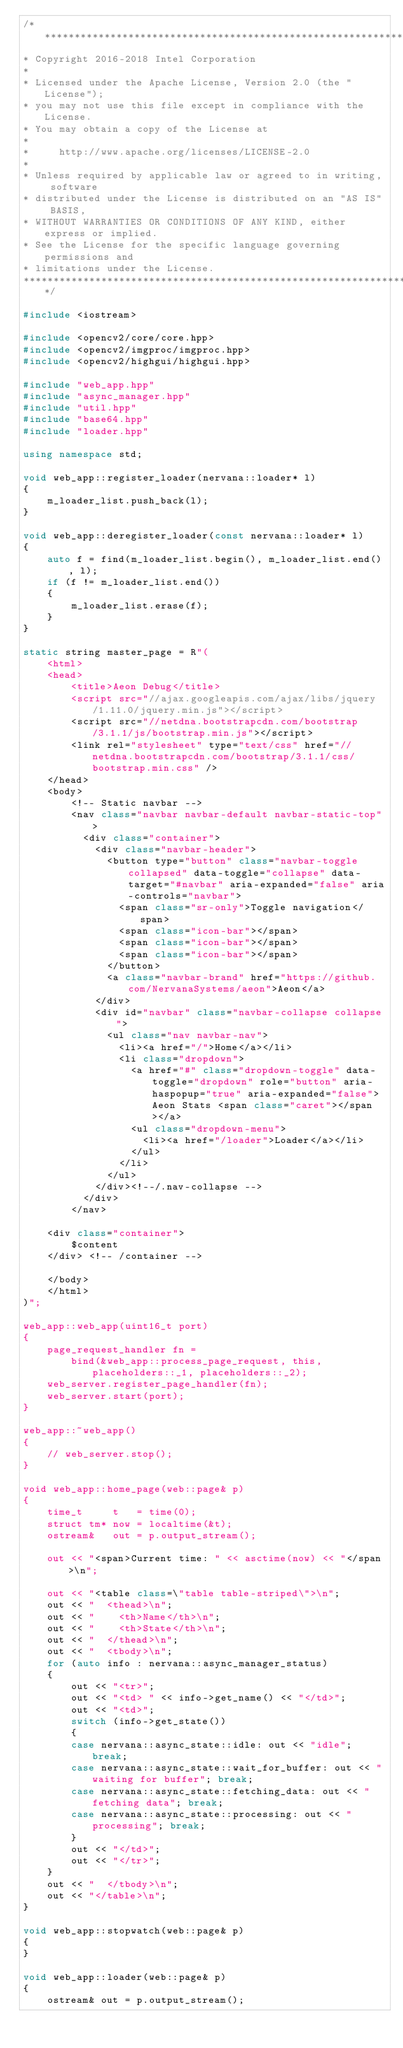<code> <loc_0><loc_0><loc_500><loc_500><_C++_>/*******************************************************************************
* Copyright 2016-2018 Intel Corporation
*
* Licensed under the Apache License, Version 2.0 (the "License");
* you may not use this file except in compliance with the License.
* You may obtain a copy of the License at
*
*     http://www.apache.org/licenses/LICENSE-2.0
*
* Unless required by applicable law or agreed to in writing, software
* distributed under the License is distributed on an "AS IS" BASIS,
* WITHOUT WARRANTIES OR CONDITIONS OF ANY KIND, either express or implied.
* See the License for the specific language governing permissions and
* limitations under the License.
*******************************************************************************/

#include <iostream>

#include <opencv2/core/core.hpp>
#include <opencv2/imgproc/imgproc.hpp>
#include <opencv2/highgui/highgui.hpp>

#include "web_app.hpp"
#include "async_manager.hpp"
#include "util.hpp"
#include "base64.hpp"
#include "loader.hpp"

using namespace std;

void web_app::register_loader(nervana::loader* l)
{
    m_loader_list.push_back(l);
}

void web_app::deregister_loader(const nervana::loader* l)
{
    auto f = find(m_loader_list.begin(), m_loader_list.end(), l);
    if (f != m_loader_list.end())
    {
        m_loader_list.erase(f);
    }
}

static string master_page = R"(
    <html>
    <head>
        <title>Aeon Debug</title>
        <script src="//ajax.googleapis.com/ajax/libs/jquery/1.11.0/jquery.min.js"></script>
        <script src="//netdna.bootstrapcdn.com/bootstrap/3.1.1/js/bootstrap.min.js"></script>
        <link rel="stylesheet" type="text/css" href="//netdna.bootstrapcdn.com/bootstrap/3.1.1/css/bootstrap.min.css" />
    </head>
    <body>
        <!-- Static navbar -->
        <nav class="navbar navbar-default navbar-static-top">
          <div class="container">
            <div class="navbar-header">
              <button type="button" class="navbar-toggle collapsed" data-toggle="collapse" data-target="#navbar" aria-expanded="false" aria-controls="navbar">
                <span class="sr-only">Toggle navigation</span>
                <span class="icon-bar"></span>
                <span class="icon-bar"></span>
                <span class="icon-bar"></span>
              </button>
              <a class="navbar-brand" href="https://github.com/NervanaSystems/aeon">Aeon</a>
            </div>
            <div id="navbar" class="navbar-collapse collapse">
              <ul class="nav navbar-nav">
                <li><a href="/">Home</a></li>
                <li class="dropdown">
                  <a href="#" class="dropdown-toggle" data-toggle="dropdown" role="button" aria-haspopup="true" aria-expanded="false">Aeon Stats <span class="caret"></span></a>
                  <ul class="dropdown-menu">
                    <li><a href="/loader">Loader</a></li>
                  </ul>
                </li>
              </ul>
            </div><!--/.nav-collapse -->
          </div>
        </nav>

    <div class="container">
        $content
    </div> <!-- /container -->

    </body>
    </html>
)";

web_app::web_app(uint16_t port)
{
    page_request_handler fn =
        bind(&web_app::process_page_request, this, placeholders::_1, placeholders::_2);
    web_server.register_page_handler(fn);
    web_server.start(port);
}

web_app::~web_app()
{
    // web_server.stop();
}

void web_app::home_page(web::page& p)
{
    time_t     t   = time(0);
    struct tm* now = localtime(&t);
    ostream&   out = p.output_stream();

    out << "<span>Current time: " << asctime(now) << "</span>\n";

    out << "<table class=\"table table-striped\">\n";
    out << "  <thead>\n";
    out << "    <th>Name</th>\n";
    out << "    <th>State</th>\n";
    out << "  </thead>\n";
    out << "  <tbody>\n";
    for (auto info : nervana::async_manager_status)
    {
        out << "<tr>";
        out << "<td> " << info->get_name() << "</td>";
        out << "<td>";
        switch (info->get_state())
        {
        case nervana::async_state::idle: out << "idle"; break;
        case nervana::async_state::wait_for_buffer: out << "waiting for buffer"; break;
        case nervana::async_state::fetching_data: out << "fetching data"; break;
        case nervana::async_state::processing: out << "processing"; break;
        }
        out << "</td>";
        out << "</tr>";
    }
    out << "  </tbody>\n";
    out << "</table>\n";
}

void web_app::stopwatch(web::page& p)
{
}

void web_app::loader(web::page& p)
{
    ostream& out = p.output_stream();
</code> 